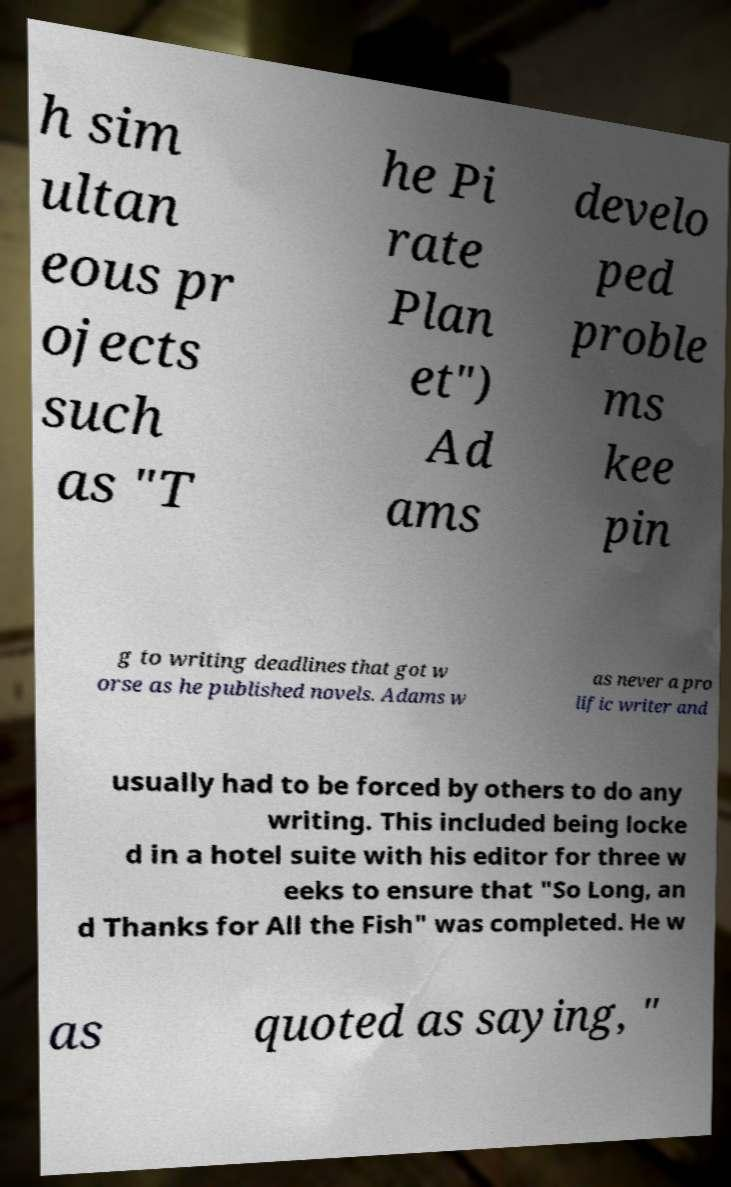For documentation purposes, I need the text within this image transcribed. Could you provide that? h sim ultan eous pr ojects such as "T he Pi rate Plan et") Ad ams develo ped proble ms kee pin g to writing deadlines that got w orse as he published novels. Adams w as never a pro lific writer and usually had to be forced by others to do any writing. This included being locke d in a hotel suite with his editor for three w eeks to ensure that "So Long, an d Thanks for All the Fish" was completed. He w as quoted as saying, " 